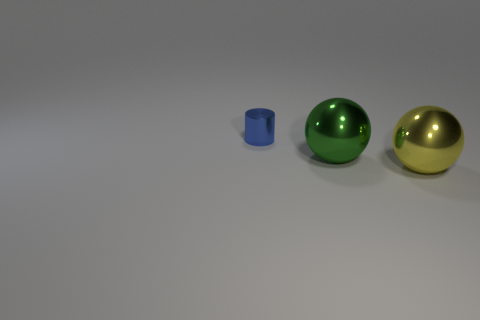Are there any other things that are the same shape as the blue object?
Make the answer very short. No. Are there any green things on the left side of the small blue cylinder?
Give a very brief answer. No. How many blue metallic objects are on the right side of the large metallic sphere on the right side of the big green metallic thing?
Offer a very short reply. 0. There is a green ball that is the same size as the yellow object; what is its material?
Offer a terse response. Metal. How many other objects are the same material as the blue cylinder?
Provide a short and direct response. 2. What number of tiny metallic things are behind the tiny blue cylinder?
Your response must be concise. 0. What number of cylinders are either green things or small objects?
Keep it short and to the point. 1. There is a thing that is to the left of the big yellow object and in front of the blue metallic cylinder; what is its size?
Your response must be concise. Large. Is the green thing made of the same material as the object that is on the right side of the large green object?
Offer a terse response. Yes. What number of objects are either large metal spheres behind the yellow shiny object or blue shiny cylinders?
Your response must be concise. 2. 